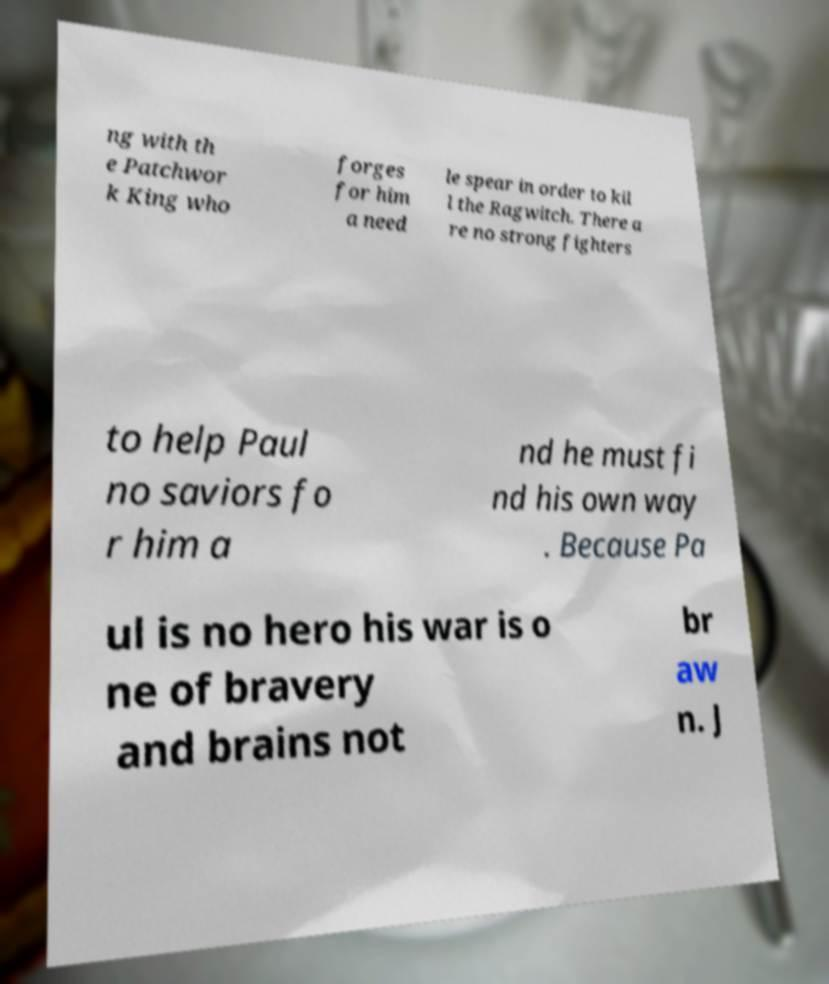Please identify and transcribe the text found in this image. ng with th e Patchwor k King who forges for him a need le spear in order to kil l the Ragwitch. There a re no strong fighters to help Paul no saviors fo r him a nd he must fi nd his own way . Because Pa ul is no hero his war is o ne of bravery and brains not br aw n. J 